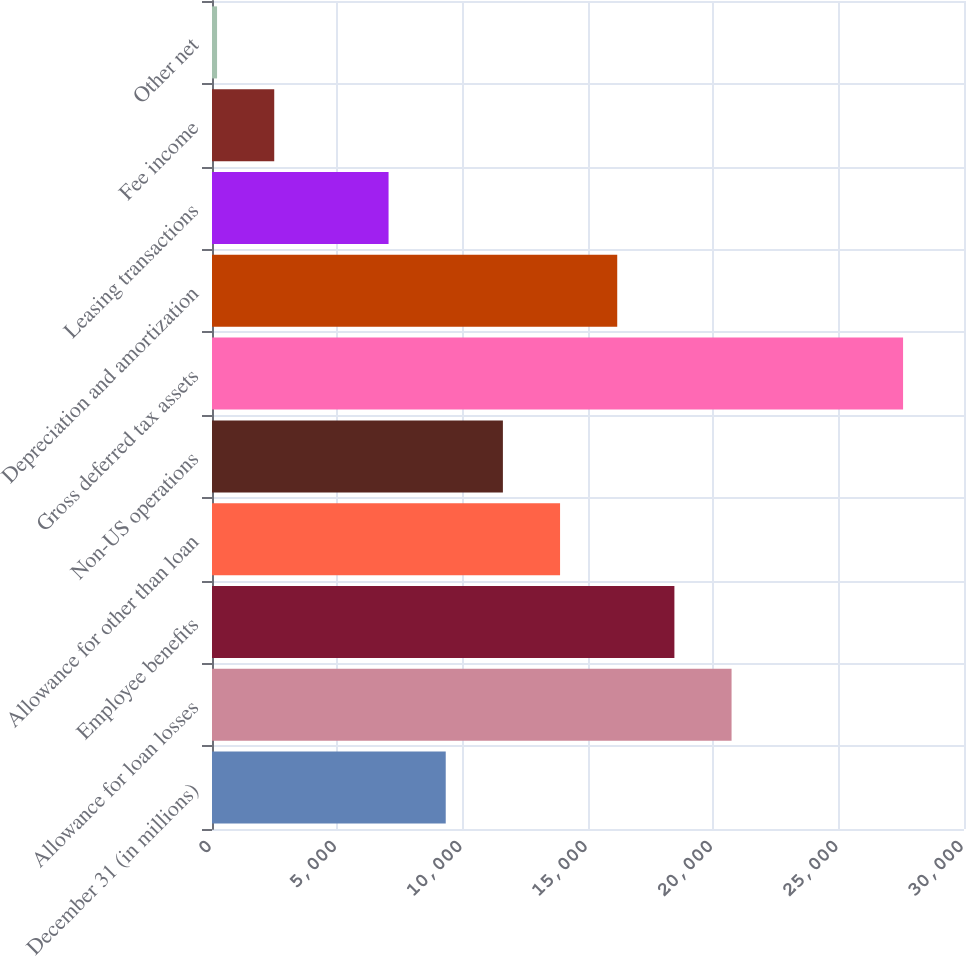Convert chart to OTSL. <chart><loc_0><loc_0><loc_500><loc_500><bar_chart><fcel>December 31 (in millions)<fcel>Allowance for loan losses<fcel>Employee benefits<fcel>Allowance for other than loan<fcel>Non-US operations<fcel>Gross deferred tax assets<fcel>Depreciation and amortization<fcel>Leasing transactions<fcel>Fee income<fcel>Other net<nl><fcel>9324.4<fcel>20727.4<fcel>18446.8<fcel>13885.6<fcel>11605<fcel>27569.2<fcel>16166.2<fcel>7043.8<fcel>2482.6<fcel>202<nl></chart> 